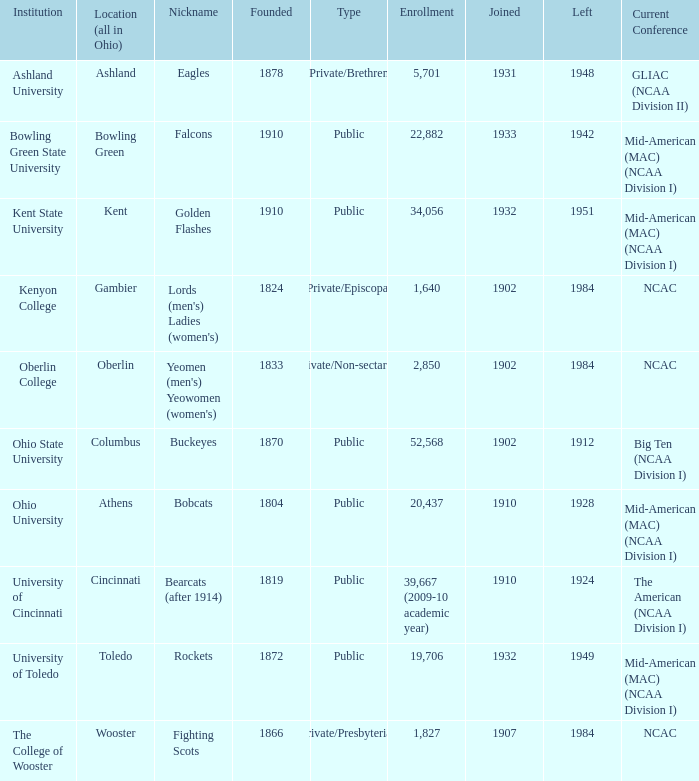What is the matriculation for ashland university? 5701.0. 